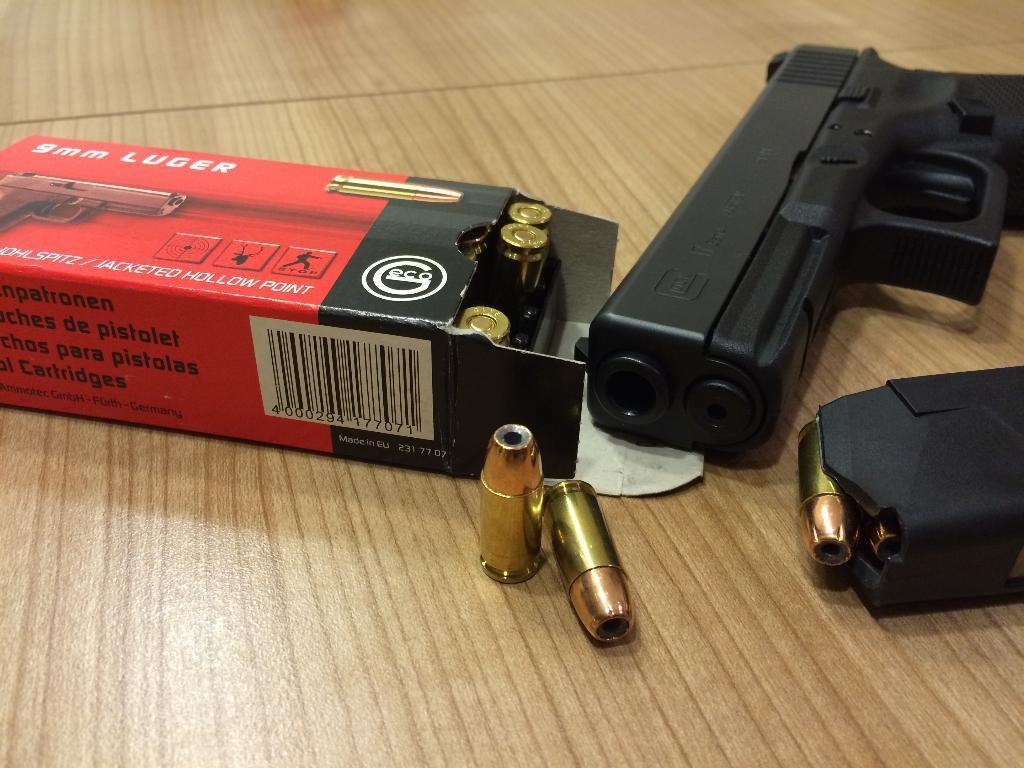In one or two sentences, can you explain what this image depicts? This image is taken indoors. At the bottom of the image there is a table with a gun and a box with a few bullets on it. 